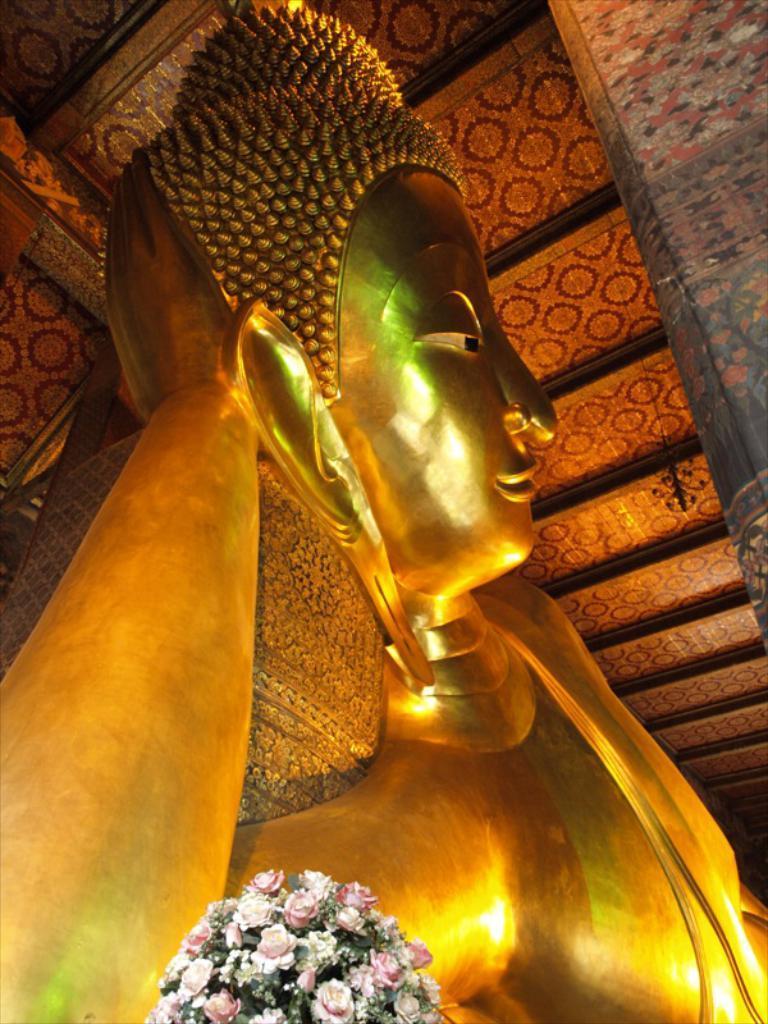How would you summarize this image in a sentence or two? As we can see in the image there are statues and flowers. 